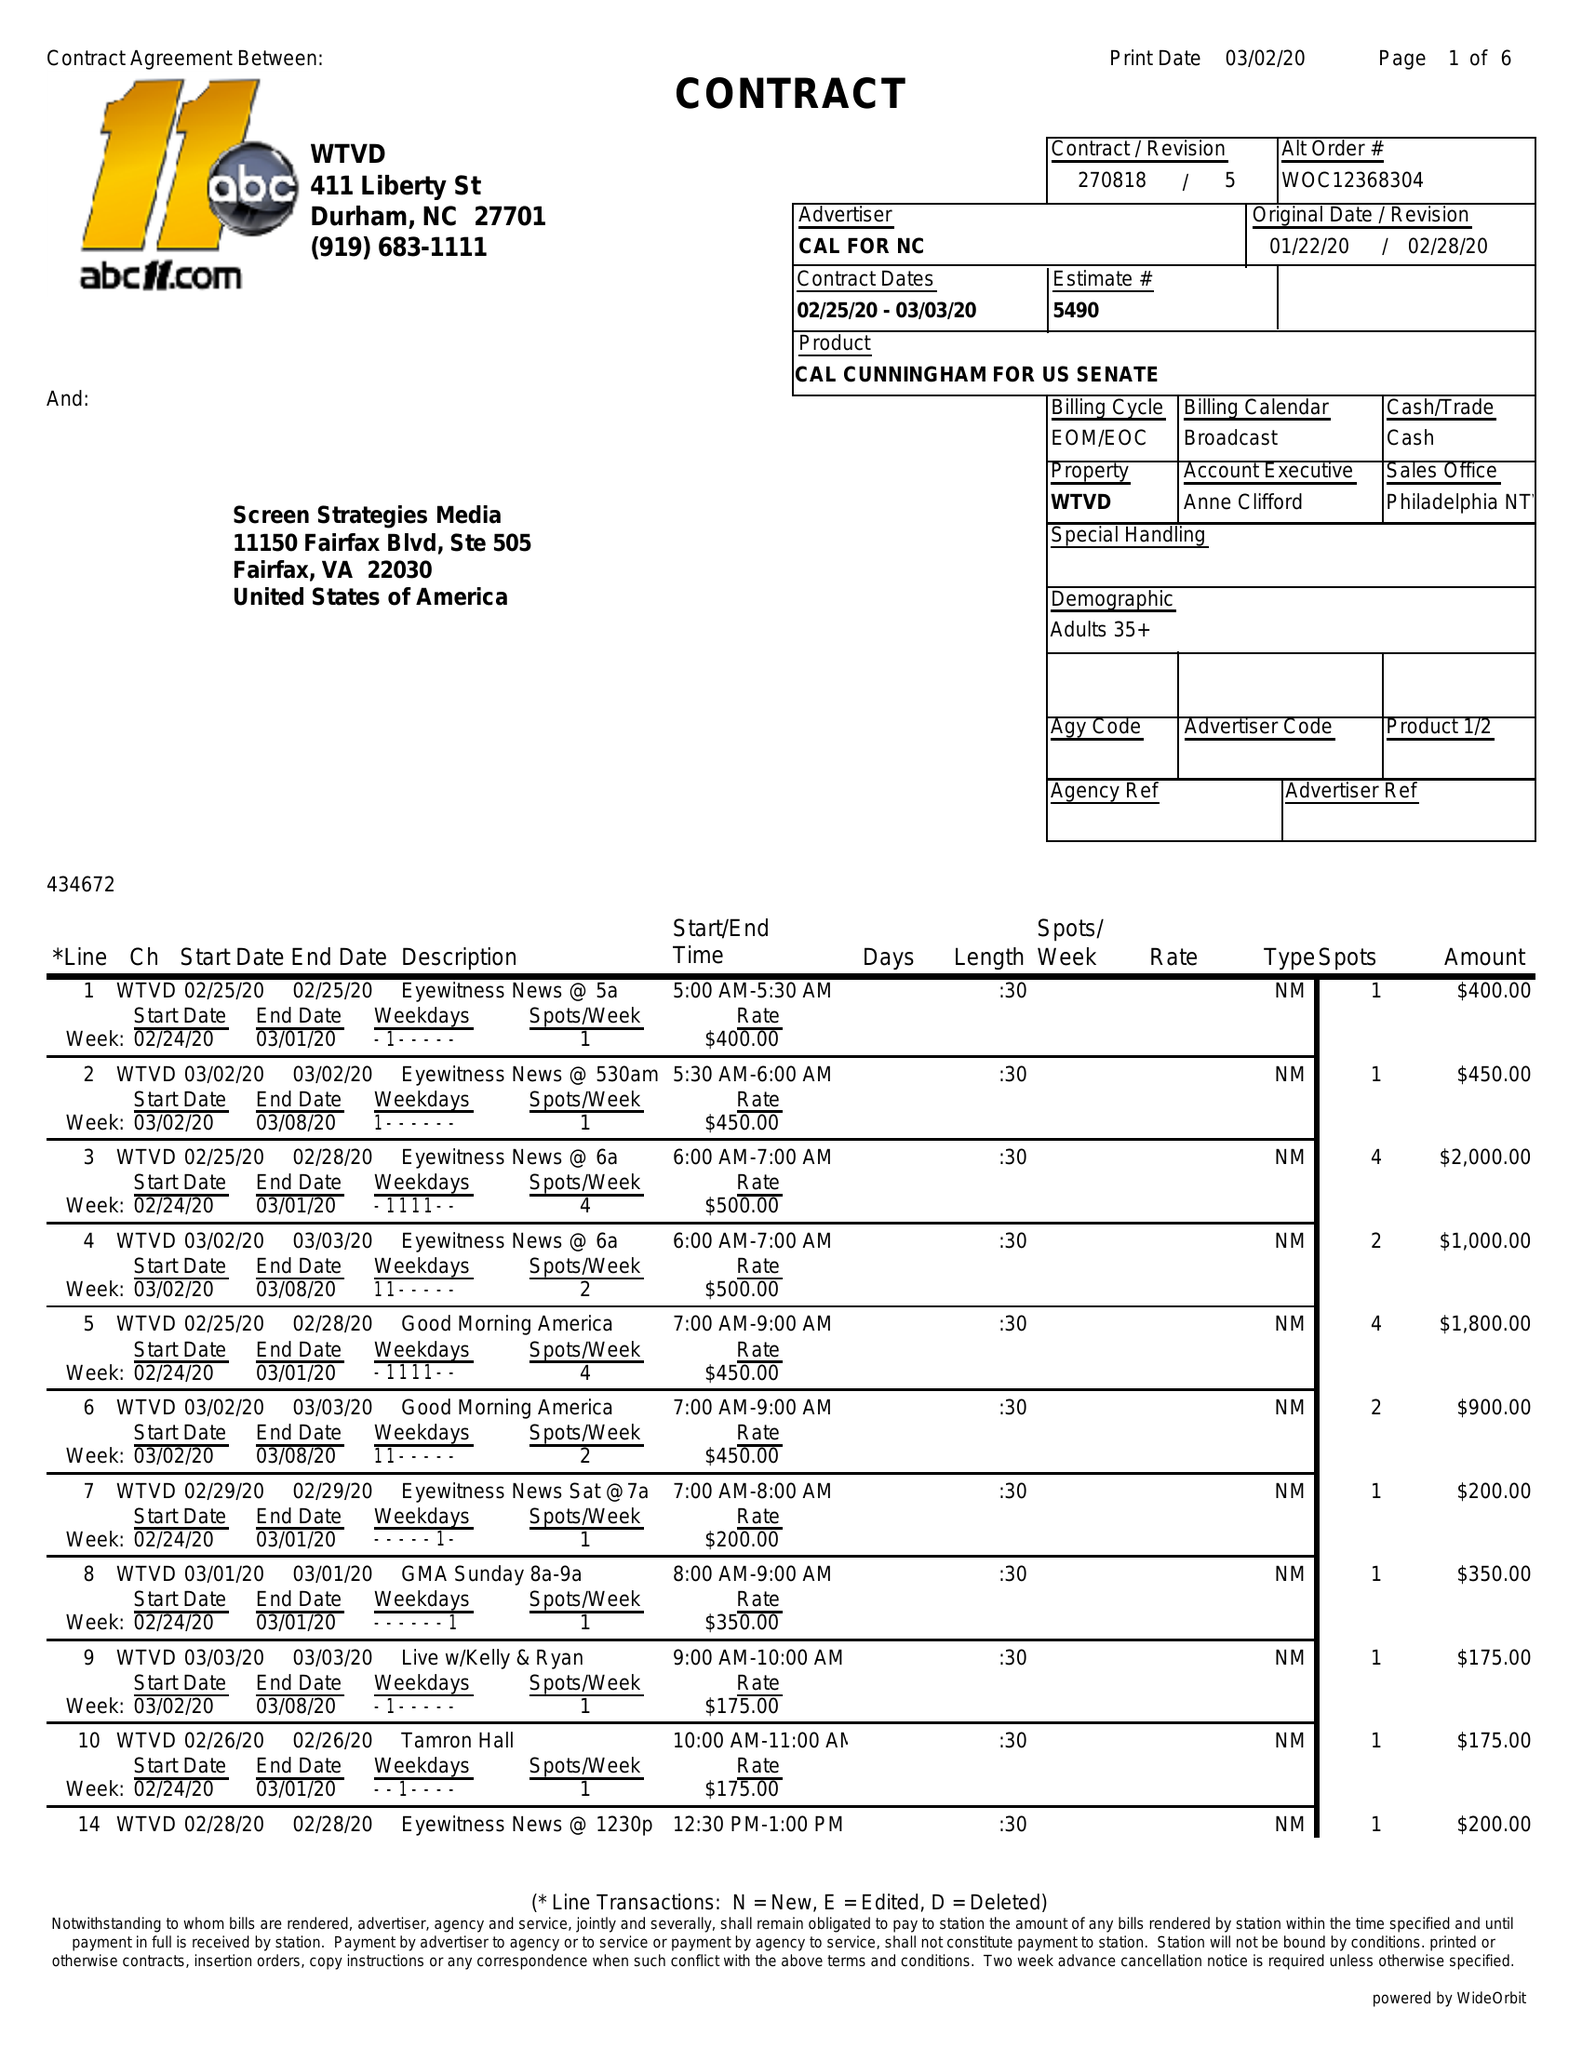What is the value for the advertiser?
Answer the question using a single word or phrase. CAL FOR NC 